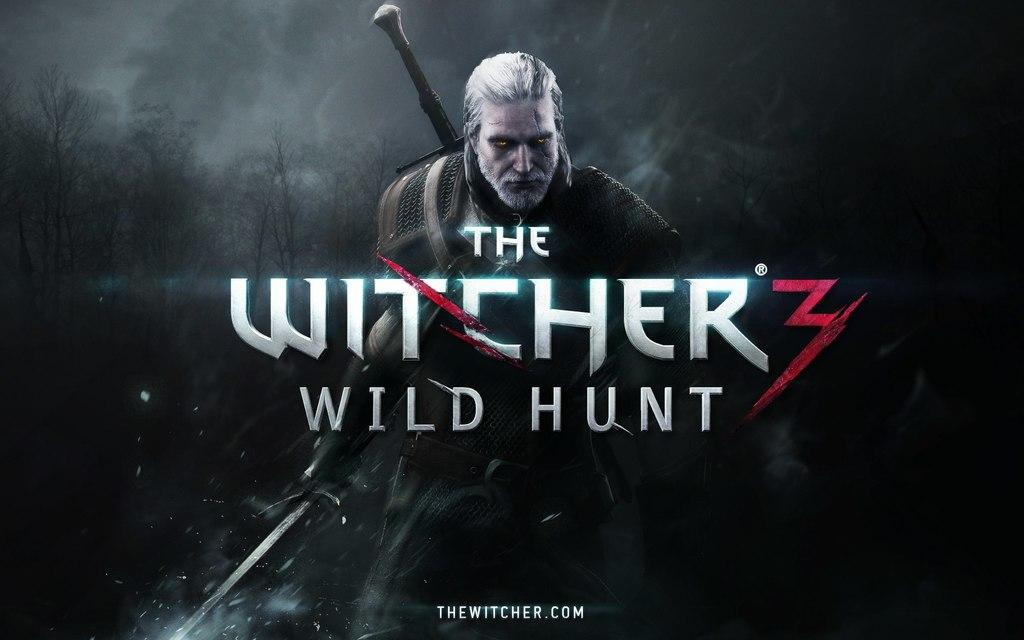<image>
Render a clear and concise summary of the photo. A warrior with white hair holding a sword with the word "The Witcher 3 Wild Hunt" in front of him. 